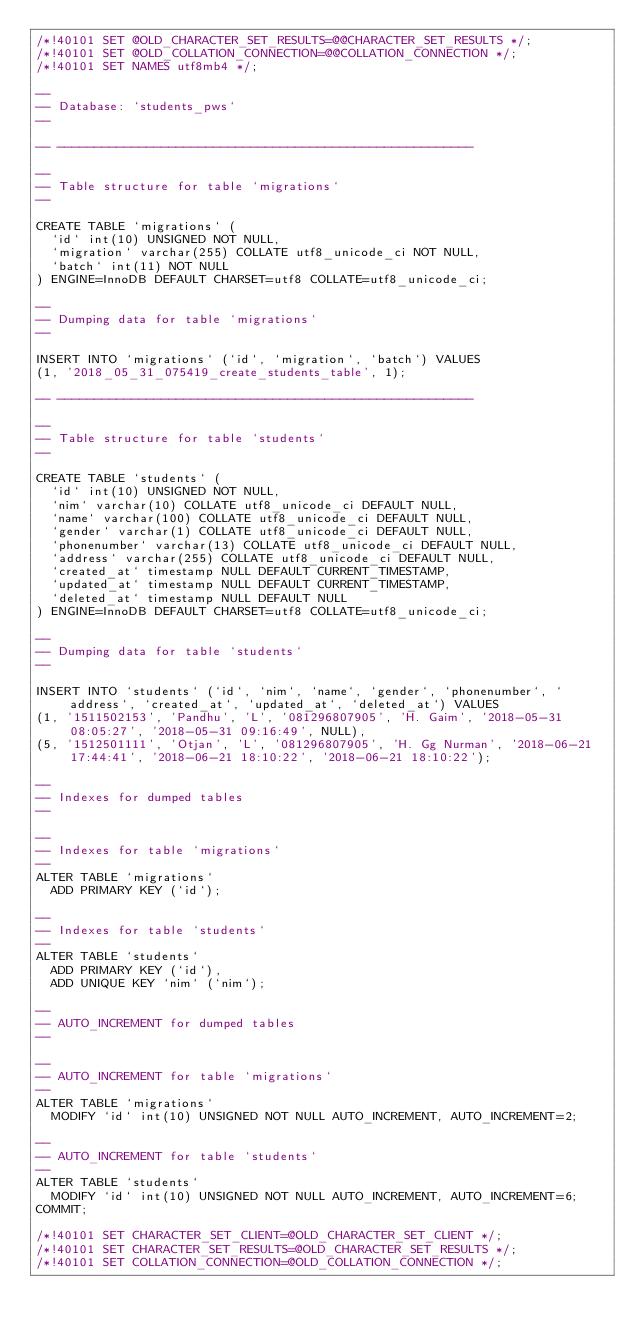<code> <loc_0><loc_0><loc_500><loc_500><_SQL_>/*!40101 SET @OLD_CHARACTER_SET_RESULTS=@@CHARACTER_SET_RESULTS */;
/*!40101 SET @OLD_COLLATION_CONNECTION=@@COLLATION_CONNECTION */;
/*!40101 SET NAMES utf8mb4 */;

--
-- Database: `students_pws`
--

-- --------------------------------------------------------

--
-- Table structure for table `migrations`
--

CREATE TABLE `migrations` (
  `id` int(10) UNSIGNED NOT NULL,
  `migration` varchar(255) COLLATE utf8_unicode_ci NOT NULL,
  `batch` int(11) NOT NULL
) ENGINE=InnoDB DEFAULT CHARSET=utf8 COLLATE=utf8_unicode_ci;

--
-- Dumping data for table `migrations`
--

INSERT INTO `migrations` (`id`, `migration`, `batch`) VALUES
(1, '2018_05_31_075419_create_students_table', 1);

-- --------------------------------------------------------

--
-- Table structure for table `students`
--

CREATE TABLE `students` (
  `id` int(10) UNSIGNED NOT NULL,
  `nim` varchar(10) COLLATE utf8_unicode_ci DEFAULT NULL,
  `name` varchar(100) COLLATE utf8_unicode_ci DEFAULT NULL,
  `gender` varchar(1) COLLATE utf8_unicode_ci DEFAULT NULL,
  `phonenumber` varchar(13) COLLATE utf8_unicode_ci DEFAULT NULL,
  `address` varchar(255) COLLATE utf8_unicode_ci DEFAULT NULL,
  `created_at` timestamp NULL DEFAULT CURRENT_TIMESTAMP,
  `updated_at` timestamp NULL DEFAULT CURRENT_TIMESTAMP,
  `deleted_at` timestamp NULL DEFAULT NULL
) ENGINE=InnoDB DEFAULT CHARSET=utf8 COLLATE=utf8_unicode_ci;

--
-- Dumping data for table `students`
--

INSERT INTO `students` (`id`, `nim`, `name`, `gender`, `phonenumber`, `address`, `created_at`, `updated_at`, `deleted_at`) VALUES
(1, '1511502153', 'Pandhu', 'L', '081296807905', 'H. Gaim', '2018-05-31 08:05:27', '2018-05-31 09:16:49', NULL),
(5, '1512501111', 'Otjan', 'L', '081296807905', 'H. Gg Nurman', '2018-06-21 17:44:41', '2018-06-21 18:10:22', '2018-06-21 18:10:22');

--
-- Indexes for dumped tables
--

--
-- Indexes for table `migrations`
--
ALTER TABLE `migrations`
  ADD PRIMARY KEY (`id`);

--
-- Indexes for table `students`
--
ALTER TABLE `students`
  ADD PRIMARY KEY (`id`),
  ADD UNIQUE KEY `nim` (`nim`);

--
-- AUTO_INCREMENT for dumped tables
--

--
-- AUTO_INCREMENT for table `migrations`
--
ALTER TABLE `migrations`
  MODIFY `id` int(10) UNSIGNED NOT NULL AUTO_INCREMENT, AUTO_INCREMENT=2;

--
-- AUTO_INCREMENT for table `students`
--
ALTER TABLE `students`
  MODIFY `id` int(10) UNSIGNED NOT NULL AUTO_INCREMENT, AUTO_INCREMENT=6;
COMMIT;

/*!40101 SET CHARACTER_SET_CLIENT=@OLD_CHARACTER_SET_CLIENT */;
/*!40101 SET CHARACTER_SET_RESULTS=@OLD_CHARACTER_SET_RESULTS */;
/*!40101 SET COLLATION_CONNECTION=@OLD_COLLATION_CONNECTION */;
</code> 